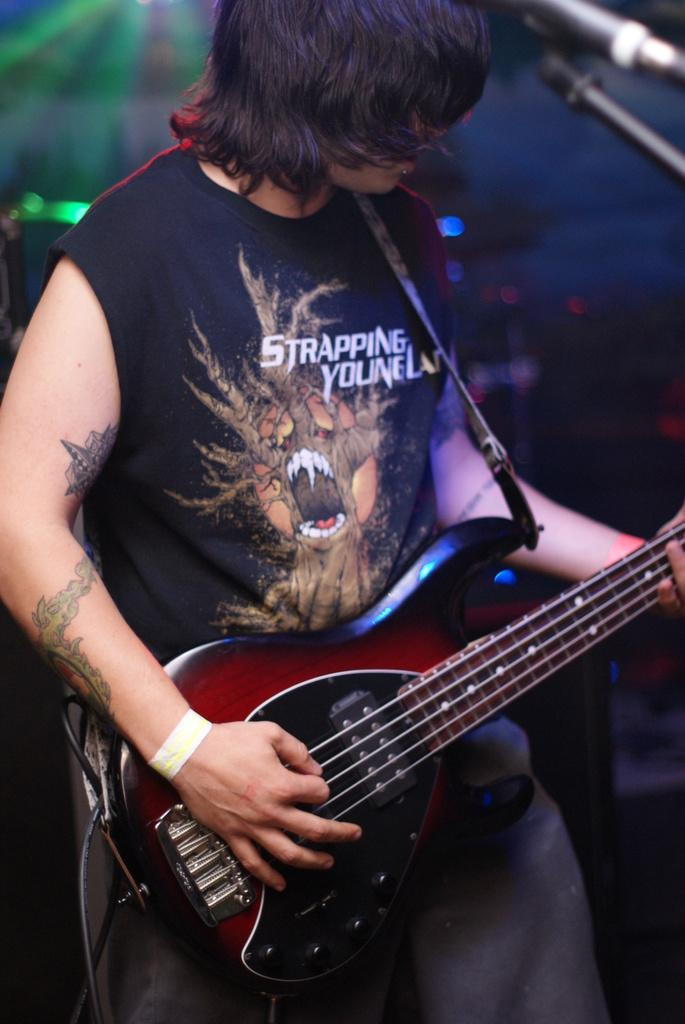What is the main subject of the image? There is a person in the image. What is the person doing in the image? The person is standing and playing a musical instrument. Can you describe any distinguishing features of the person? The person has a tattoo on their hand. What type of hat is the person wearing in the image? There is no hat visible in the image. What trade does the person in the image practice? The image does not provide information about the person's trade or profession. 